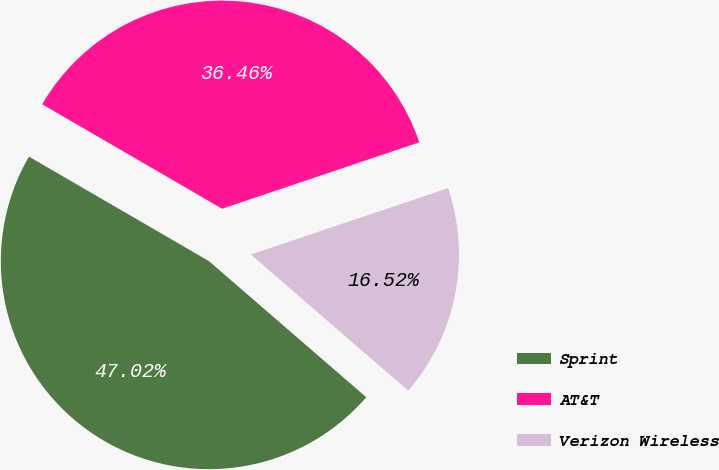Convert chart to OTSL. <chart><loc_0><loc_0><loc_500><loc_500><pie_chart><fcel>Sprint<fcel>AT&T<fcel>Verizon Wireless<nl><fcel>47.02%<fcel>36.46%<fcel>16.52%<nl></chart> 